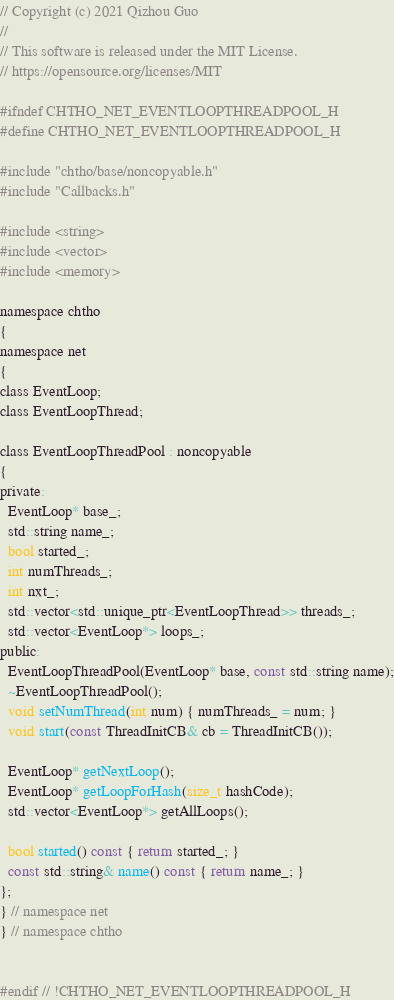Convert code to text. <code><loc_0><loc_0><loc_500><loc_500><_C_>// Copyright (c) 2021 Qizhou Guo
// 
// This software is released under the MIT License.
// https://opensource.org/licenses/MIT

#ifndef CHTHO_NET_EVENTLOOPTHREADPOOL_H
#define CHTHO_NET_EVENTLOOPTHREADPOOL_H

#include "chtho/base/noncopyable.h"
#include "Callbacks.h"

#include <string>
#include <vector>
#include <memory> 

namespace chtho
{
namespace net
{
class EventLoop;
class EventLoopThread;

class EventLoopThreadPool : noncopyable
{
private:
  EventLoop* base_;
  std::string name_;
  bool started_;
  int numThreads_;
  int nxt_;
  std::vector<std::unique_ptr<EventLoopThread>> threads_;
  std::vector<EventLoop*> loops_;
public:
  EventLoopThreadPool(EventLoop* base, const std::string name);
  ~EventLoopThreadPool();
  void setNumThread(int num) { numThreads_ = num; }
  void start(const ThreadInitCB& cb = ThreadInitCB());

  EventLoop* getNextLoop();
  EventLoop* getLoopForHash(size_t hashCode);
  std::vector<EventLoop*> getAllLoops();

  bool started() const { return started_; }
  const std::string& name() const { return name_; }
};
} // namespace net
} // namespace chtho


#endif // !CHTHO_NET_EVENTLOOPTHREADPOOL_H</code> 